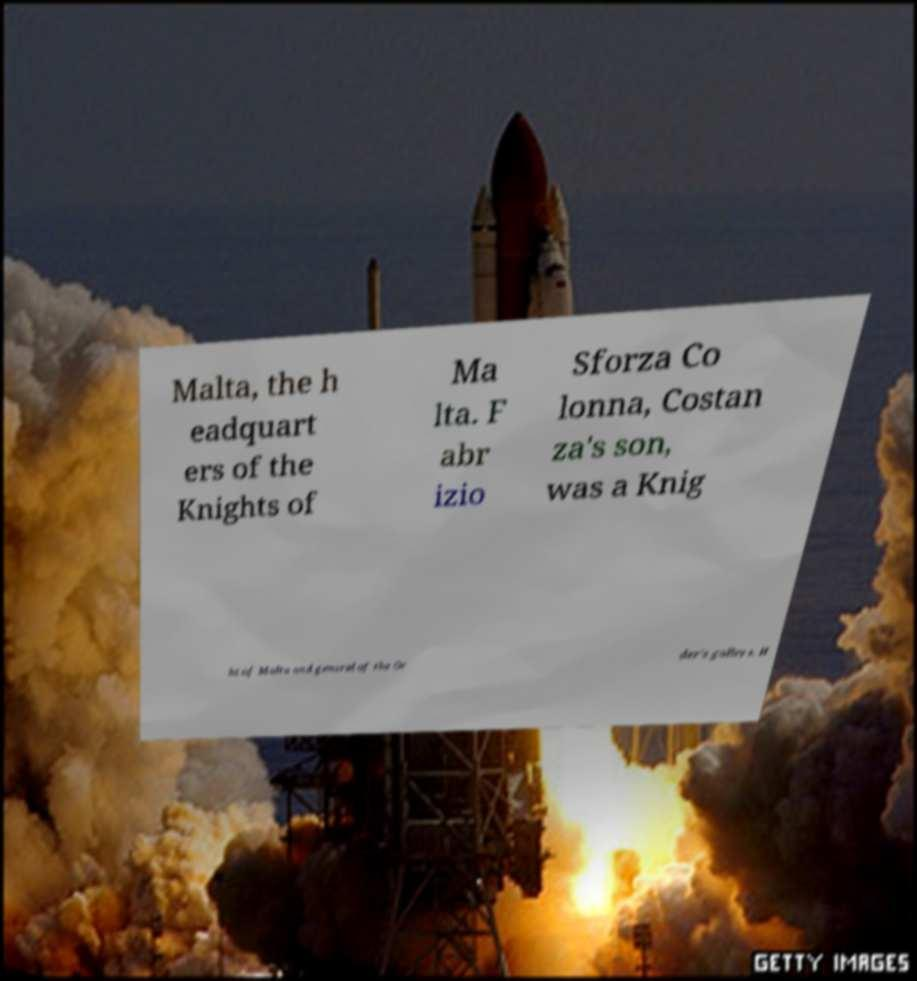There's text embedded in this image that I need extracted. Can you transcribe it verbatim? Malta, the h eadquart ers of the Knights of Ma lta. F abr izio Sforza Co lonna, Costan za's son, was a Knig ht of Malta and general of the Or der's galleys. H 